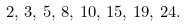<formula> <loc_0><loc_0><loc_500><loc_500>2 , \, 3 , \, 5 , \, 8 , \, 1 0 , \, 1 5 , \, 1 9 , \, 2 4 .</formula> 